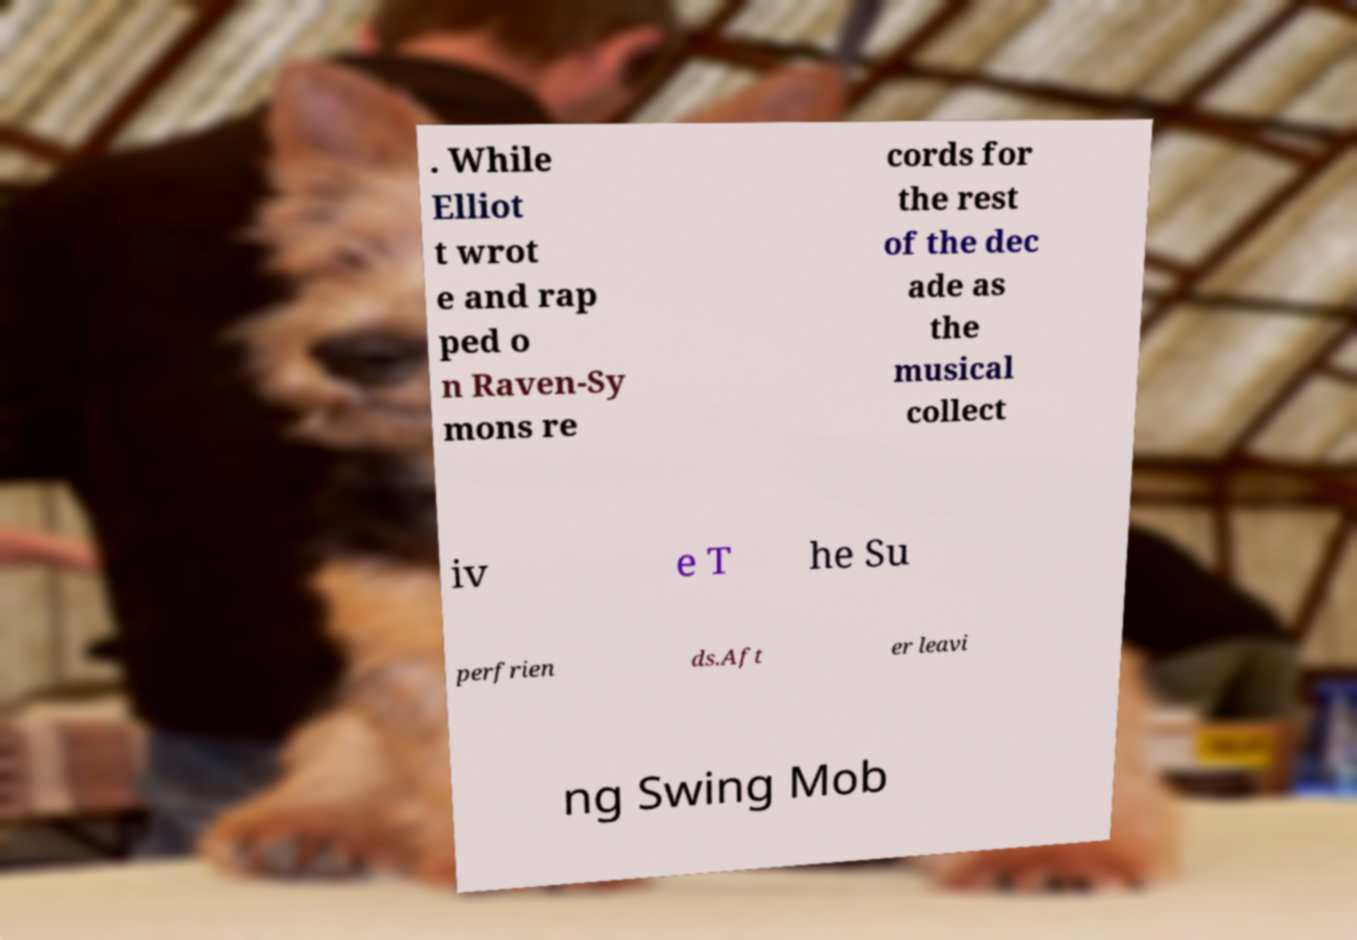Could you extract and type out the text from this image? . While Elliot t wrot e and rap ped o n Raven-Sy mons re cords for the rest of the dec ade as the musical collect iv e T he Su perfrien ds.Aft er leavi ng Swing Mob 